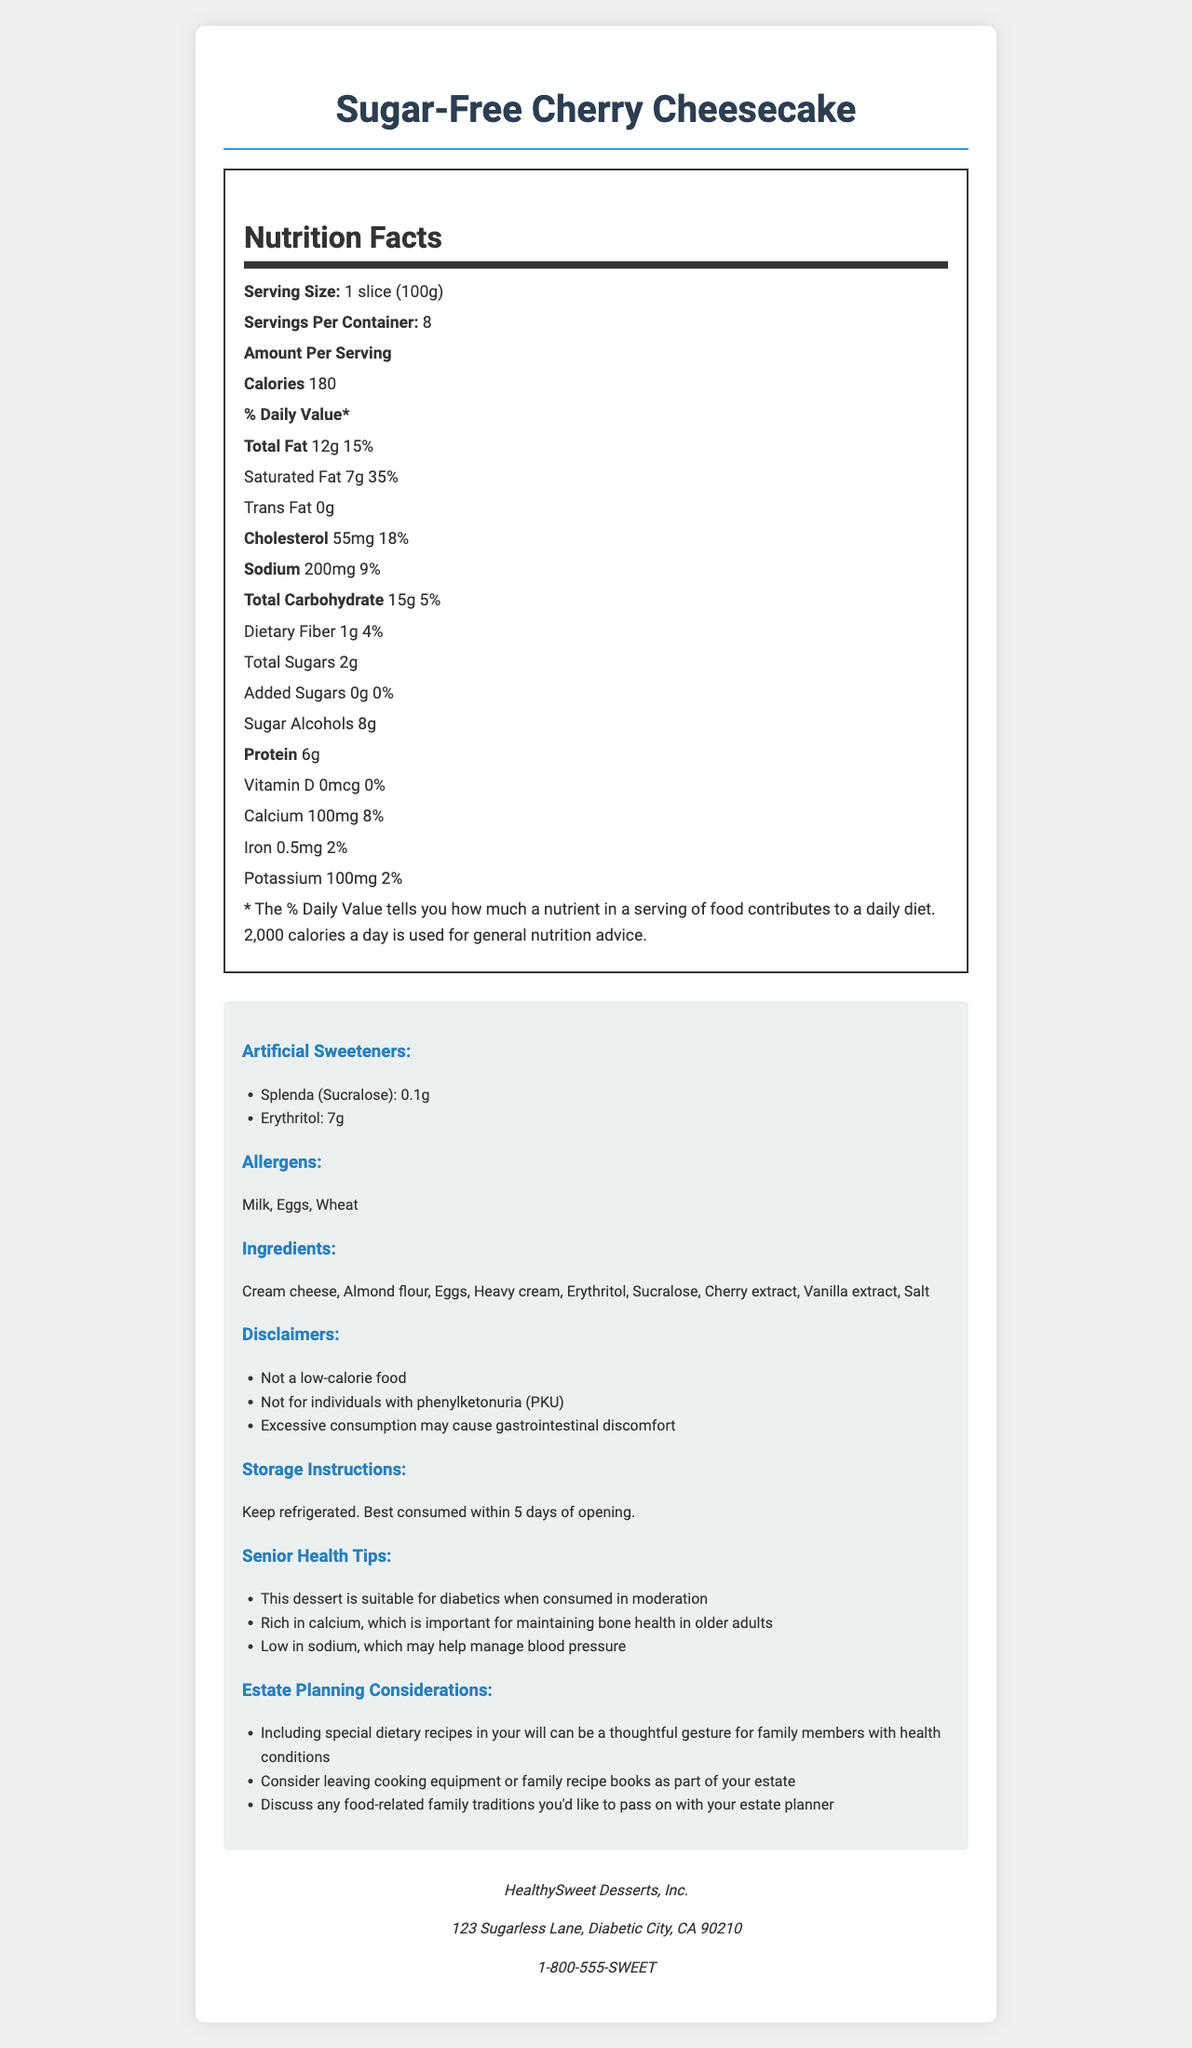what is the serving size? The serving size is listed as "1 slice (100g)" in the Nutrition Facts section.
Answer: 1 slice (100g) how many servings per container are there? The document states that there are 8 servings per container.
Answer: 8 how many calories are in one serving? According to the Nutrition Facts, each serving contains 180 calories.
Answer: 180 how much saturated fat is there per serving? The document displays the amount of saturated fat per serving as 7g.
Answer: 7g what are the total carbohydrates in one serving? The total carbohydrates for one serving are listed as 15g.
Answer: 15g which artificial sweeteners are used in the product? A. Aspartame and Stevia B. Splenda (Sucralose) and Erythritol C. Saccharin and Xylitol The document mentions the artificial sweeteners Splenda (Sucralose) and Erythritol.
Answer: B. Splenda (Sucralose) and Erythritol which of the following nutrients is highest in percentage of daily value per serving? A. Calcium B. Iron C. Sodium D. Saturated Fat The document states that saturated fat has a daily value percentage of 35%, which is the highest among the given options.
Answer: D. Saturated Fat is this product suitable for individuals with PKU? The disclaimers section explicitly states "Not for individuals with phenylketonuria (PKU)".
Answer: No does the dessert need to be refrigerated? The storage instructions clearly state "Keep refrigerated."
Answer: Yes how many allergens are listed for this product? The document lists three allergens: Milk, Eggs, and Wheat.
Answer: 3 describe the main idea of the document. The document outlines nutritional values, ingredients, allergens, artificial sweeteners, disclaimers, and consumption/storage instructions. Additionally, it offers health tips for seniors and estate planning considerations related to dietary preferences.
Answer: The document provides detailed nutrition information, ingredients, and additional health tips for a Sugar-Free Cherry Cheesecake, aimed primarily at diabetics and people concerned with health and dietary restrictions. what is the manufacturer's contact information? The document lists the manufacturer's phone number as 1-800-555-SWEET.
Answer: 1-800-555-SWEET how many grams of sugar alcohols are present per serving? The nutrition label indicates that there are 8g of sugar alcohols per serving.
Answer: 8g what is the daily value percentage of sodium in one serving? The document shows that the sodium content provides 9% of the daily value.
Answer: 9% how much protein is there per serving? The document lists the amount of protein per serving as 6g.
Answer: 6g are there any calcium benefits mentioned for seniors in the document? The Senior Health Tips section mentions that the dessert is rich in calcium, which is important for maintaining bone health in older adults.
Answer: Yes which allergens are present in this product? A. Peanuts, Tree Nuts, Shellfish B. Milk, Eggs, Wheat C. Soy, Milk, Fish The document lists the allergens as Milk, Eggs, and Wheat.
Answer: B. Milk, Eggs, Wheat what is the name of the manufacturer? The manufacturer name is given as HealthySweet Desserts, Inc.
Answer: HealthySweet Desserts, Inc. can we determine the price of the product from this document? The document doesn't provide any information about the price of the product.
Answer: Cannot be determined 